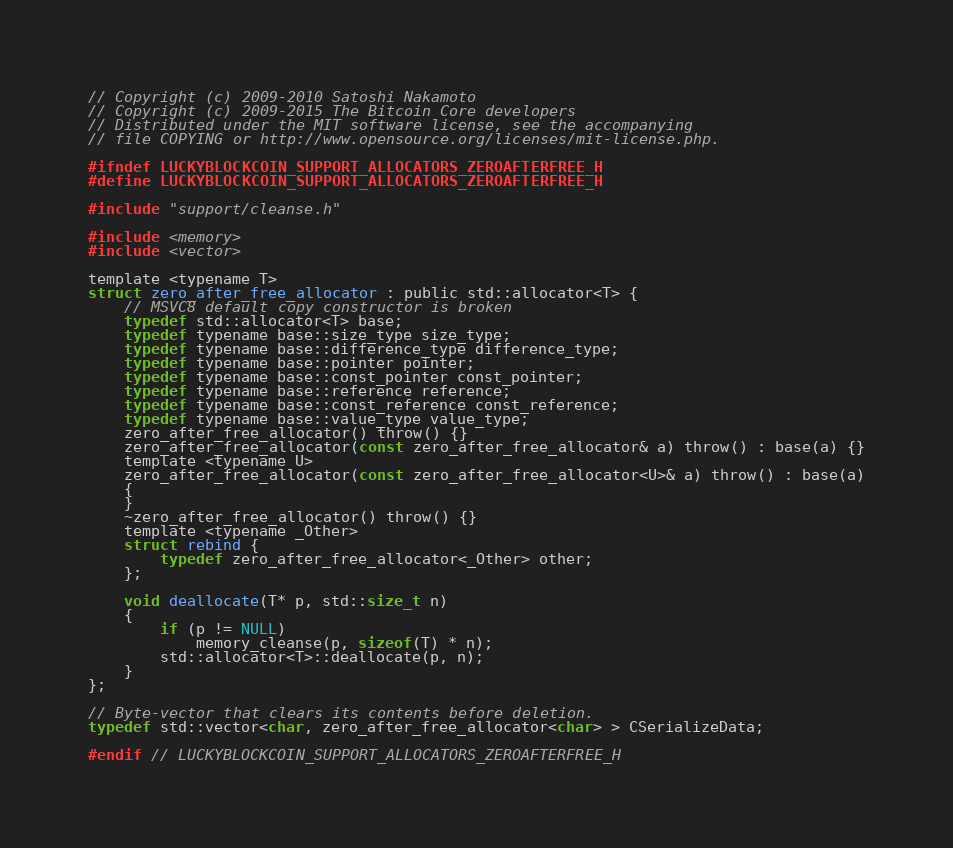Convert code to text. <code><loc_0><loc_0><loc_500><loc_500><_C_>// Copyright (c) 2009-2010 Satoshi Nakamoto
// Copyright (c) 2009-2015 The Bitcoin Core developers
// Distributed under the MIT software license, see the accompanying
// file COPYING or http://www.opensource.org/licenses/mit-license.php.

#ifndef LUCKYBLOCKCOIN_SUPPORT_ALLOCATORS_ZEROAFTERFREE_H
#define LUCKYBLOCKCOIN_SUPPORT_ALLOCATORS_ZEROAFTERFREE_H

#include "support/cleanse.h"

#include <memory>
#include <vector>

template <typename T>
struct zero_after_free_allocator : public std::allocator<T> {
    // MSVC8 default copy constructor is broken
    typedef std::allocator<T> base;
    typedef typename base::size_type size_type;
    typedef typename base::difference_type difference_type;
    typedef typename base::pointer pointer;
    typedef typename base::const_pointer const_pointer;
    typedef typename base::reference reference;
    typedef typename base::const_reference const_reference;
    typedef typename base::value_type value_type;
    zero_after_free_allocator() throw() {}
    zero_after_free_allocator(const zero_after_free_allocator& a) throw() : base(a) {}
    template <typename U>
    zero_after_free_allocator(const zero_after_free_allocator<U>& a) throw() : base(a)
    {
    }
    ~zero_after_free_allocator() throw() {}
    template <typename _Other>
    struct rebind {
        typedef zero_after_free_allocator<_Other> other;
    };

    void deallocate(T* p, std::size_t n)
    {
        if (p != NULL)
            memory_cleanse(p, sizeof(T) * n);
        std::allocator<T>::deallocate(p, n);
    }
};

// Byte-vector that clears its contents before deletion.
typedef std::vector<char, zero_after_free_allocator<char> > CSerializeData;

#endif // LUCKYBLOCKCOIN_SUPPORT_ALLOCATORS_ZEROAFTERFREE_H
</code> 